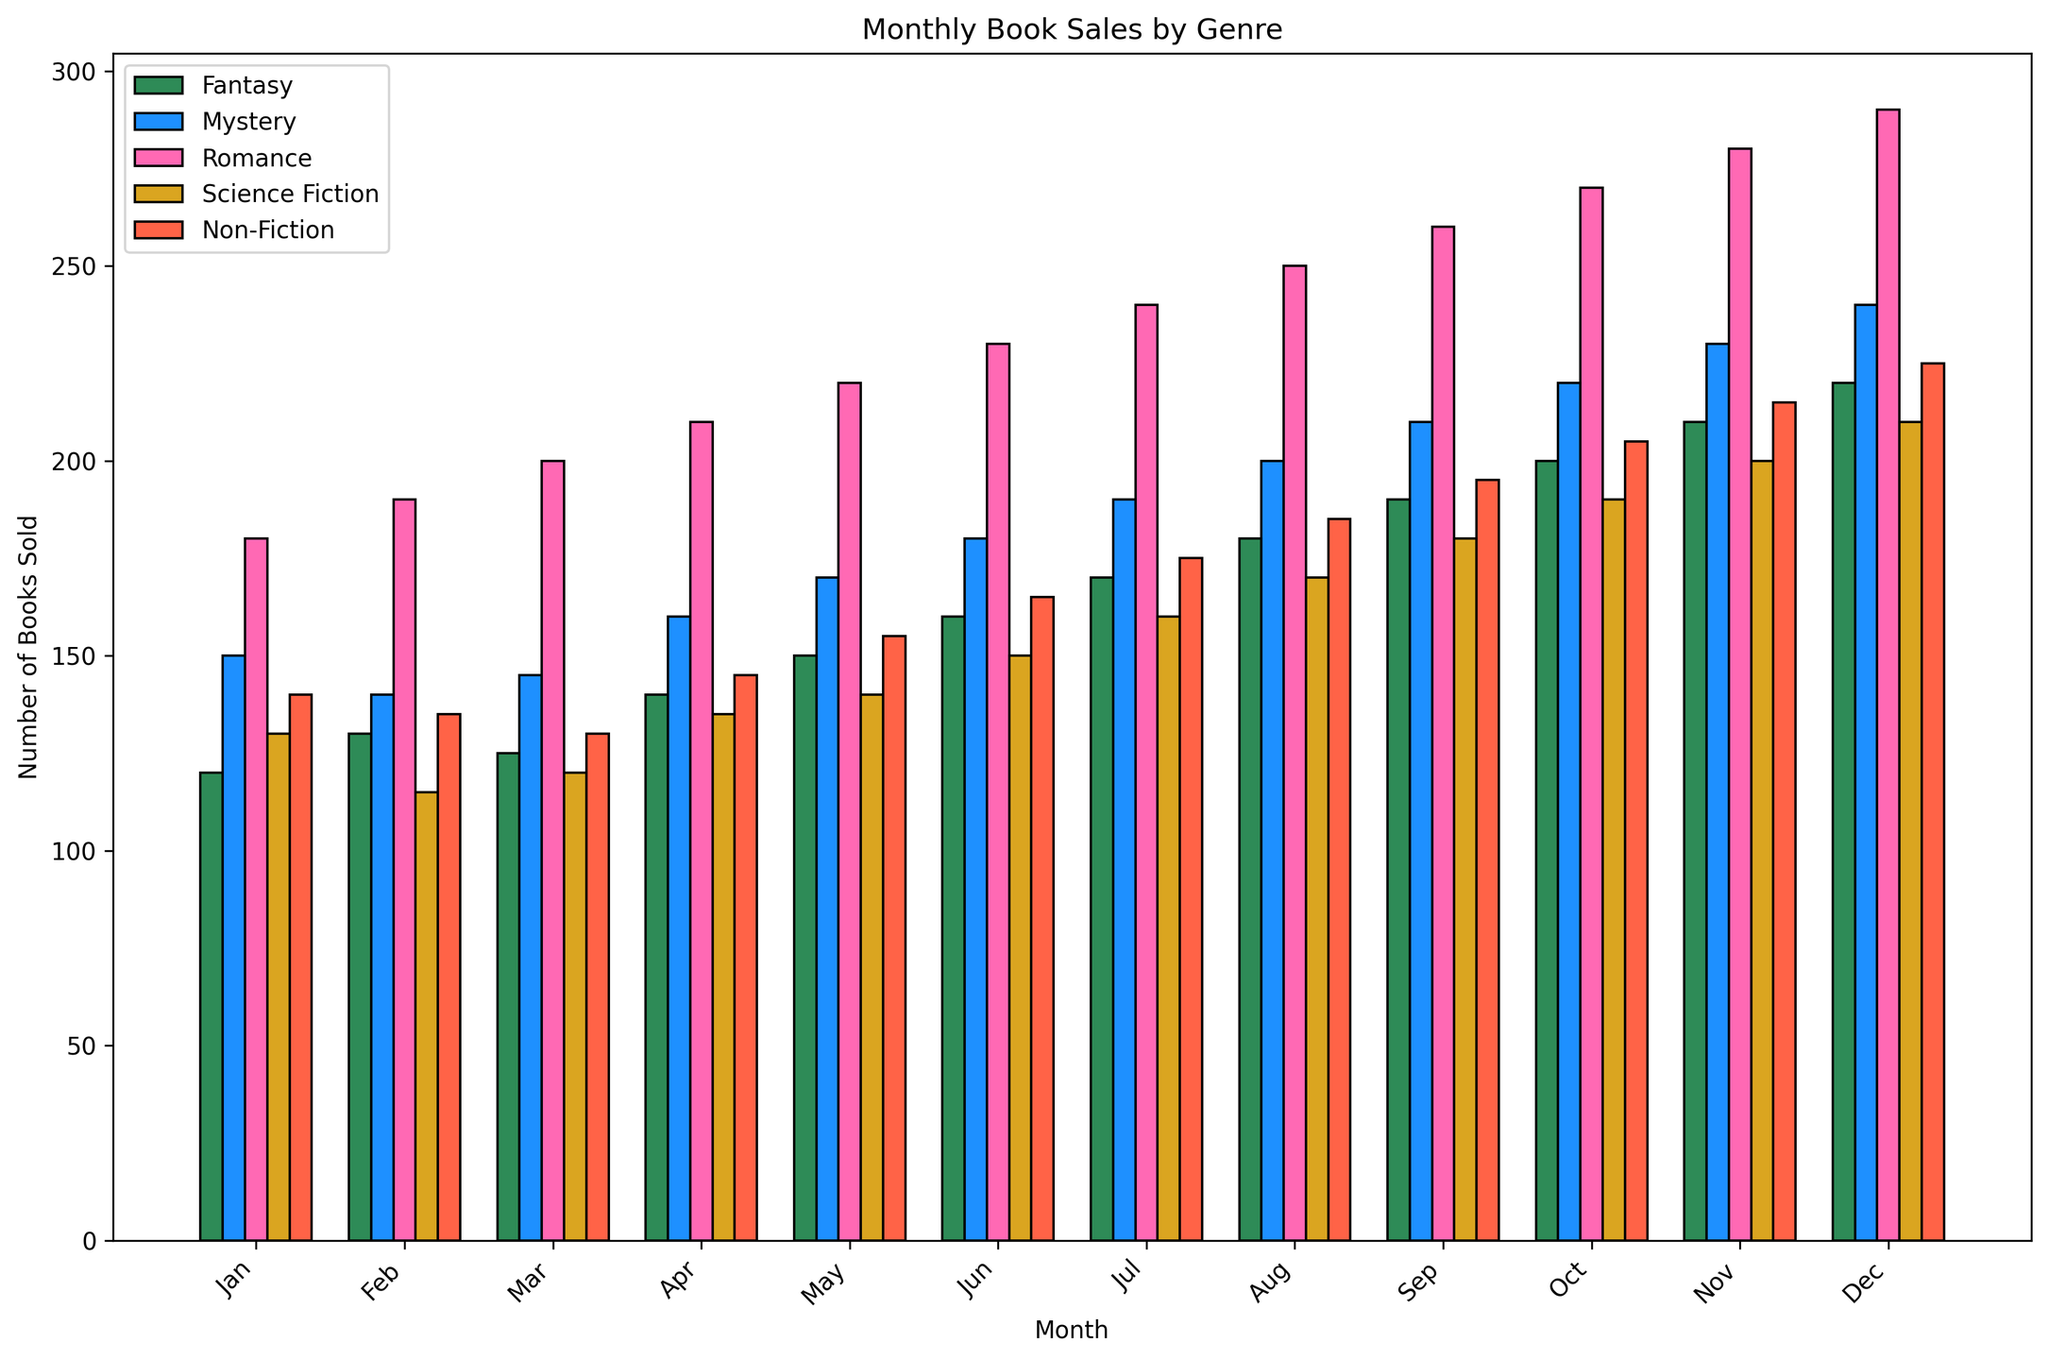What is the highest number of books sold in any month for the Romance genre? The highest bar in the Romance genre is in December, reaching 290 books sold.
Answer: 290 Which genre had the lowest number of books sold in June? In June, the Science Fiction genre had the lowest sales of 150 books.
Answer: Science Fiction What is the difference in book sales between Fantasy and Non-Fiction in October? In October, Fantasy sold 200 books and Non-Fiction sold 205 books. The difference is 205 - 200 = 5 books.
Answer: 5 In what month did Mystery sales surpass Fantasy sales by the largest margin? The largest margin of difference for Mystery over Fantasy is in December, where Mystery sold 240 books, and Fantasy sold 220 books, a difference of 240 - 220 = 20 books.
Answer: December What is the total number of Science Fiction books sold over the year? Adding the monthly sales: 130 + 115 + 120 + 135 + 140 + 150 + 160 + 170 + 180 + 190 + 200 + 210 = 1900 books.
Answer: 1900 Which month shows the highest combined sales of all genres? In December, the combined sales are: 220 (Fantasy) + 240 (Mystery) + 290 (Romance) + 210 (Science Fiction) + 225 (Non-Fiction) = 1185 books.
Answer: December What is the average number of Romance books sold per month? Total sales of Romance over the year is 180 + 190 + 200 + 210 + 220 + 230 + 240 + 250 + 260 + 270 + 280 + 290 = 2820 books. There are 12 months, so the average is 2820 / 12 = 235 books per month.
Answer: 235 Which genre consistently shows an increasing trend in sales across the months? Observing the bars, Romance shows a consistently increasing trend each month, rising from 180 in January to 290 in December.
Answer: Romance 